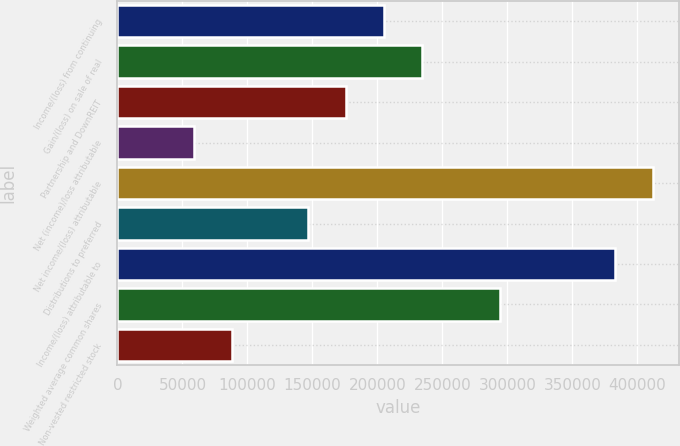Convert chart. <chart><loc_0><loc_0><loc_500><loc_500><bar_chart><fcel>Income/(loss) from continuing<fcel>Gain/(loss) on sale of real<fcel>Partnership and DownREIT<fcel>Net (income)/loss attributable<fcel>Net income/(loss) attributable<fcel>Distributions to preferred<fcel>Income/(loss) attributable to<fcel>Weighted average common shares<fcel>Non-vested restricted stock<nl><fcel>204903<fcel>234175<fcel>175631<fcel>58544.5<fcel>411744<fcel>146360<fcel>382473<fcel>294658<fcel>87816.1<nl></chart> 